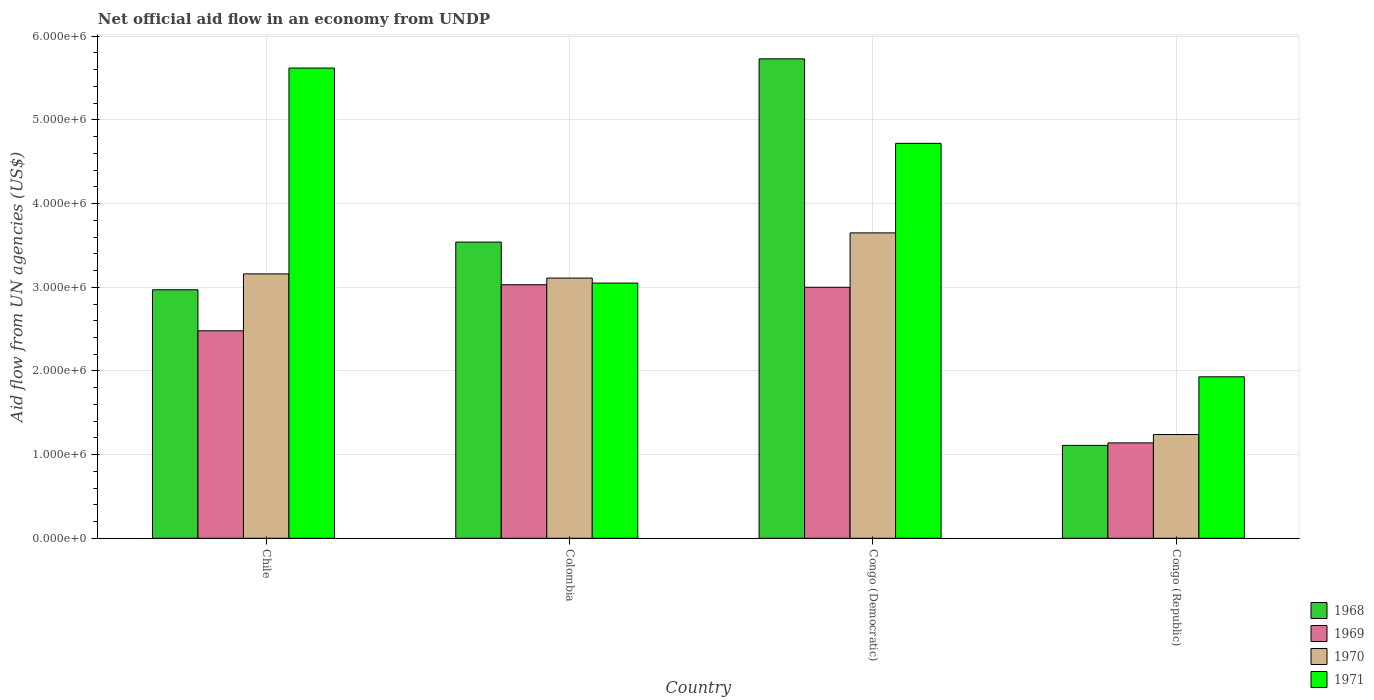How many different coloured bars are there?
Your answer should be compact. 4. Are the number of bars per tick equal to the number of legend labels?
Ensure brevity in your answer.  Yes. Are the number of bars on each tick of the X-axis equal?
Your answer should be compact. Yes. How many bars are there on the 4th tick from the left?
Offer a terse response. 4. What is the label of the 4th group of bars from the left?
Offer a terse response. Congo (Republic). In how many cases, is the number of bars for a given country not equal to the number of legend labels?
Give a very brief answer. 0. What is the net official aid flow in 1969 in Congo (Republic)?
Provide a short and direct response. 1.14e+06. Across all countries, what is the maximum net official aid flow in 1970?
Provide a succinct answer. 3.65e+06. Across all countries, what is the minimum net official aid flow in 1971?
Offer a terse response. 1.93e+06. In which country was the net official aid flow in 1969 maximum?
Keep it short and to the point. Colombia. In which country was the net official aid flow in 1968 minimum?
Your answer should be very brief. Congo (Republic). What is the total net official aid flow in 1971 in the graph?
Offer a terse response. 1.53e+07. What is the difference between the net official aid flow in 1968 in Colombia and that in Congo (Democratic)?
Provide a short and direct response. -2.19e+06. What is the difference between the net official aid flow in 1970 in Chile and the net official aid flow in 1969 in Colombia?
Make the answer very short. 1.30e+05. What is the average net official aid flow in 1971 per country?
Keep it short and to the point. 3.83e+06. In how many countries, is the net official aid flow in 1969 greater than 4400000 US$?
Offer a very short reply. 0. What is the ratio of the net official aid flow in 1971 in Chile to that in Colombia?
Provide a short and direct response. 1.84. Is the difference between the net official aid flow in 1970 in Colombia and Congo (Democratic) greater than the difference between the net official aid flow in 1969 in Colombia and Congo (Democratic)?
Offer a terse response. No. What is the difference between the highest and the second highest net official aid flow in 1969?
Offer a very short reply. 5.50e+05. What is the difference between the highest and the lowest net official aid flow in 1970?
Ensure brevity in your answer.  2.41e+06. In how many countries, is the net official aid flow in 1968 greater than the average net official aid flow in 1968 taken over all countries?
Offer a very short reply. 2. Is it the case that in every country, the sum of the net official aid flow in 1968 and net official aid flow in 1970 is greater than the sum of net official aid flow in 1969 and net official aid flow in 1971?
Make the answer very short. No. What does the 1st bar from the left in Congo (Republic) represents?
Provide a short and direct response. 1968. How many countries are there in the graph?
Provide a short and direct response. 4. What is the difference between two consecutive major ticks on the Y-axis?
Your answer should be compact. 1.00e+06. Are the values on the major ticks of Y-axis written in scientific E-notation?
Give a very brief answer. Yes. How many legend labels are there?
Your answer should be compact. 4. What is the title of the graph?
Keep it short and to the point. Net official aid flow in an economy from UNDP. Does "1999" appear as one of the legend labels in the graph?
Provide a short and direct response. No. What is the label or title of the Y-axis?
Provide a succinct answer. Aid flow from UN agencies (US$). What is the Aid flow from UN agencies (US$) in 1968 in Chile?
Ensure brevity in your answer.  2.97e+06. What is the Aid flow from UN agencies (US$) in 1969 in Chile?
Your answer should be very brief. 2.48e+06. What is the Aid flow from UN agencies (US$) in 1970 in Chile?
Provide a succinct answer. 3.16e+06. What is the Aid flow from UN agencies (US$) in 1971 in Chile?
Make the answer very short. 5.62e+06. What is the Aid flow from UN agencies (US$) in 1968 in Colombia?
Ensure brevity in your answer.  3.54e+06. What is the Aid flow from UN agencies (US$) of 1969 in Colombia?
Your answer should be very brief. 3.03e+06. What is the Aid flow from UN agencies (US$) in 1970 in Colombia?
Your answer should be very brief. 3.11e+06. What is the Aid flow from UN agencies (US$) in 1971 in Colombia?
Offer a terse response. 3.05e+06. What is the Aid flow from UN agencies (US$) of 1968 in Congo (Democratic)?
Offer a very short reply. 5.73e+06. What is the Aid flow from UN agencies (US$) in 1969 in Congo (Democratic)?
Give a very brief answer. 3.00e+06. What is the Aid flow from UN agencies (US$) of 1970 in Congo (Democratic)?
Your answer should be compact. 3.65e+06. What is the Aid flow from UN agencies (US$) of 1971 in Congo (Democratic)?
Your response must be concise. 4.72e+06. What is the Aid flow from UN agencies (US$) in 1968 in Congo (Republic)?
Ensure brevity in your answer.  1.11e+06. What is the Aid flow from UN agencies (US$) in 1969 in Congo (Republic)?
Your answer should be compact. 1.14e+06. What is the Aid flow from UN agencies (US$) in 1970 in Congo (Republic)?
Provide a short and direct response. 1.24e+06. What is the Aid flow from UN agencies (US$) of 1971 in Congo (Republic)?
Provide a short and direct response. 1.93e+06. Across all countries, what is the maximum Aid flow from UN agencies (US$) in 1968?
Your response must be concise. 5.73e+06. Across all countries, what is the maximum Aid flow from UN agencies (US$) in 1969?
Offer a terse response. 3.03e+06. Across all countries, what is the maximum Aid flow from UN agencies (US$) of 1970?
Provide a succinct answer. 3.65e+06. Across all countries, what is the maximum Aid flow from UN agencies (US$) of 1971?
Keep it short and to the point. 5.62e+06. Across all countries, what is the minimum Aid flow from UN agencies (US$) of 1968?
Offer a very short reply. 1.11e+06. Across all countries, what is the minimum Aid flow from UN agencies (US$) of 1969?
Your response must be concise. 1.14e+06. Across all countries, what is the minimum Aid flow from UN agencies (US$) of 1970?
Your answer should be very brief. 1.24e+06. Across all countries, what is the minimum Aid flow from UN agencies (US$) of 1971?
Your answer should be compact. 1.93e+06. What is the total Aid flow from UN agencies (US$) in 1968 in the graph?
Your response must be concise. 1.34e+07. What is the total Aid flow from UN agencies (US$) in 1969 in the graph?
Offer a terse response. 9.65e+06. What is the total Aid flow from UN agencies (US$) of 1970 in the graph?
Your answer should be compact. 1.12e+07. What is the total Aid flow from UN agencies (US$) of 1971 in the graph?
Provide a short and direct response. 1.53e+07. What is the difference between the Aid flow from UN agencies (US$) in 1968 in Chile and that in Colombia?
Keep it short and to the point. -5.70e+05. What is the difference between the Aid flow from UN agencies (US$) in 1969 in Chile and that in Colombia?
Your answer should be very brief. -5.50e+05. What is the difference between the Aid flow from UN agencies (US$) of 1971 in Chile and that in Colombia?
Provide a short and direct response. 2.57e+06. What is the difference between the Aid flow from UN agencies (US$) in 1968 in Chile and that in Congo (Democratic)?
Offer a very short reply. -2.76e+06. What is the difference between the Aid flow from UN agencies (US$) of 1969 in Chile and that in Congo (Democratic)?
Offer a very short reply. -5.20e+05. What is the difference between the Aid flow from UN agencies (US$) of 1970 in Chile and that in Congo (Democratic)?
Offer a terse response. -4.90e+05. What is the difference between the Aid flow from UN agencies (US$) of 1968 in Chile and that in Congo (Republic)?
Make the answer very short. 1.86e+06. What is the difference between the Aid flow from UN agencies (US$) of 1969 in Chile and that in Congo (Republic)?
Give a very brief answer. 1.34e+06. What is the difference between the Aid flow from UN agencies (US$) of 1970 in Chile and that in Congo (Republic)?
Your answer should be very brief. 1.92e+06. What is the difference between the Aid flow from UN agencies (US$) of 1971 in Chile and that in Congo (Republic)?
Offer a very short reply. 3.69e+06. What is the difference between the Aid flow from UN agencies (US$) of 1968 in Colombia and that in Congo (Democratic)?
Your answer should be compact. -2.19e+06. What is the difference between the Aid flow from UN agencies (US$) of 1969 in Colombia and that in Congo (Democratic)?
Your answer should be very brief. 3.00e+04. What is the difference between the Aid flow from UN agencies (US$) of 1970 in Colombia and that in Congo (Democratic)?
Ensure brevity in your answer.  -5.40e+05. What is the difference between the Aid flow from UN agencies (US$) in 1971 in Colombia and that in Congo (Democratic)?
Keep it short and to the point. -1.67e+06. What is the difference between the Aid flow from UN agencies (US$) in 1968 in Colombia and that in Congo (Republic)?
Offer a very short reply. 2.43e+06. What is the difference between the Aid flow from UN agencies (US$) in 1969 in Colombia and that in Congo (Republic)?
Your response must be concise. 1.89e+06. What is the difference between the Aid flow from UN agencies (US$) of 1970 in Colombia and that in Congo (Republic)?
Offer a terse response. 1.87e+06. What is the difference between the Aid flow from UN agencies (US$) of 1971 in Colombia and that in Congo (Republic)?
Your answer should be very brief. 1.12e+06. What is the difference between the Aid flow from UN agencies (US$) of 1968 in Congo (Democratic) and that in Congo (Republic)?
Offer a terse response. 4.62e+06. What is the difference between the Aid flow from UN agencies (US$) of 1969 in Congo (Democratic) and that in Congo (Republic)?
Offer a very short reply. 1.86e+06. What is the difference between the Aid flow from UN agencies (US$) in 1970 in Congo (Democratic) and that in Congo (Republic)?
Ensure brevity in your answer.  2.41e+06. What is the difference between the Aid flow from UN agencies (US$) of 1971 in Congo (Democratic) and that in Congo (Republic)?
Your answer should be very brief. 2.79e+06. What is the difference between the Aid flow from UN agencies (US$) of 1969 in Chile and the Aid flow from UN agencies (US$) of 1970 in Colombia?
Your response must be concise. -6.30e+05. What is the difference between the Aid flow from UN agencies (US$) of 1969 in Chile and the Aid flow from UN agencies (US$) of 1971 in Colombia?
Provide a succinct answer. -5.70e+05. What is the difference between the Aid flow from UN agencies (US$) in 1970 in Chile and the Aid flow from UN agencies (US$) in 1971 in Colombia?
Provide a short and direct response. 1.10e+05. What is the difference between the Aid flow from UN agencies (US$) of 1968 in Chile and the Aid flow from UN agencies (US$) of 1969 in Congo (Democratic)?
Offer a terse response. -3.00e+04. What is the difference between the Aid flow from UN agencies (US$) of 1968 in Chile and the Aid flow from UN agencies (US$) of 1970 in Congo (Democratic)?
Your answer should be compact. -6.80e+05. What is the difference between the Aid flow from UN agencies (US$) in 1968 in Chile and the Aid flow from UN agencies (US$) in 1971 in Congo (Democratic)?
Give a very brief answer. -1.75e+06. What is the difference between the Aid flow from UN agencies (US$) of 1969 in Chile and the Aid flow from UN agencies (US$) of 1970 in Congo (Democratic)?
Keep it short and to the point. -1.17e+06. What is the difference between the Aid flow from UN agencies (US$) in 1969 in Chile and the Aid flow from UN agencies (US$) in 1971 in Congo (Democratic)?
Your response must be concise. -2.24e+06. What is the difference between the Aid flow from UN agencies (US$) in 1970 in Chile and the Aid flow from UN agencies (US$) in 1971 in Congo (Democratic)?
Give a very brief answer. -1.56e+06. What is the difference between the Aid flow from UN agencies (US$) of 1968 in Chile and the Aid flow from UN agencies (US$) of 1969 in Congo (Republic)?
Give a very brief answer. 1.83e+06. What is the difference between the Aid flow from UN agencies (US$) in 1968 in Chile and the Aid flow from UN agencies (US$) in 1970 in Congo (Republic)?
Offer a terse response. 1.73e+06. What is the difference between the Aid flow from UN agencies (US$) in 1968 in Chile and the Aid flow from UN agencies (US$) in 1971 in Congo (Republic)?
Your answer should be very brief. 1.04e+06. What is the difference between the Aid flow from UN agencies (US$) of 1969 in Chile and the Aid flow from UN agencies (US$) of 1970 in Congo (Republic)?
Give a very brief answer. 1.24e+06. What is the difference between the Aid flow from UN agencies (US$) in 1969 in Chile and the Aid flow from UN agencies (US$) in 1971 in Congo (Republic)?
Offer a very short reply. 5.50e+05. What is the difference between the Aid flow from UN agencies (US$) of 1970 in Chile and the Aid flow from UN agencies (US$) of 1971 in Congo (Republic)?
Give a very brief answer. 1.23e+06. What is the difference between the Aid flow from UN agencies (US$) of 1968 in Colombia and the Aid flow from UN agencies (US$) of 1969 in Congo (Democratic)?
Provide a succinct answer. 5.40e+05. What is the difference between the Aid flow from UN agencies (US$) of 1968 in Colombia and the Aid flow from UN agencies (US$) of 1971 in Congo (Democratic)?
Provide a short and direct response. -1.18e+06. What is the difference between the Aid flow from UN agencies (US$) of 1969 in Colombia and the Aid flow from UN agencies (US$) of 1970 in Congo (Democratic)?
Your response must be concise. -6.20e+05. What is the difference between the Aid flow from UN agencies (US$) in 1969 in Colombia and the Aid flow from UN agencies (US$) in 1971 in Congo (Democratic)?
Your response must be concise. -1.69e+06. What is the difference between the Aid flow from UN agencies (US$) in 1970 in Colombia and the Aid flow from UN agencies (US$) in 1971 in Congo (Democratic)?
Keep it short and to the point. -1.61e+06. What is the difference between the Aid flow from UN agencies (US$) in 1968 in Colombia and the Aid flow from UN agencies (US$) in 1969 in Congo (Republic)?
Offer a very short reply. 2.40e+06. What is the difference between the Aid flow from UN agencies (US$) of 1968 in Colombia and the Aid flow from UN agencies (US$) of 1970 in Congo (Republic)?
Keep it short and to the point. 2.30e+06. What is the difference between the Aid flow from UN agencies (US$) in 1968 in Colombia and the Aid flow from UN agencies (US$) in 1971 in Congo (Republic)?
Provide a short and direct response. 1.61e+06. What is the difference between the Aid flow from UN agencies (US$) of 1969 in Colombia and the Aid flow from UN agencies (US$) of 1970 in Congo (Republic)?
Make the answer very short. 1.79e+06. What is the difference between the Aid flow from UN agencies (US$) of 1969 in Colombia and the Aid flow from UN agencies (US$) of 1971 in Congo (Republic)?
Ensure brevity in your answer.  1.10e+06. What is the difference between the Aid flow from UN agencies (US$) in 1970 in Colombia and the Aid flow from UN agencies (US$) in 1971 in Congo (Republic)?
Offer a terse response. 1.18e+06. What is the difference between the Aid flow from UN agencies (US$) of 1968 in Congo (Democratic) and the Aid flow from UN agencies (US$) of 1969 in Congo (Republic)?
Your answer should be very brief. 4.59e+06. What is the difference between the Aid flow from UN agencies (US$) of 1968 in Congo (Democratic) and the Aid flow from UN agencies (US$) of 1970 in Congo (Republic)?
Keep it short and to the point. 4.49e+06. What is the difference between the Aid flow from UN agencies (US$) of 1968 in Congo (Democratic) and the Aid flow from UN agencies (US$) of 1971 in Congo (Republic)?
Provide a short and direct response. 3.80e+06. What is the difference between the Aid flow from UN agencies (US$) of 1969 in Congo (Democratic) and the Aid flow from UN agencies (US$) of 1970 in Congo (Republic)?
Provide a short and direct response. 1.76e+06. What is the difference between the Aid flow from UN agencies (US$) in 1969 in Congo (Democratic) and the Aid flow from UN agencies (US$) in 1971 in Congo (Republic)?
Your answer should be compact. 1.07e+06. What is the difference between the Aid flow from UN agencies (US$) of 1970 in Congo (Democratic) and the Aid flow from UN agencies (US$) of 1971 in Congo (Republic)?
Provide a succinct answer. 1.72e+06. What is the average Aid flow from UN agencies (US$) of 1968 per country?
Your answer should be compact. 3.34e+06. What is the average Aid flow from UN agencies (US$) in 1969 per country?
Ensure brevity in your answer.  2.41e+06. What is the average Aid flow from UN agencies (US$) in 1970 per country?
Your response must be concise. 2.79e+06. What is the average Aid flow from UN agencies (US$) of 1971 per country?
Ensure brevity in your answer.  3.83e+06. What is the difference between the Aid flow from UN agencies (US$) in 1968 and Aid flow from UN agencies (US$) in 1969 in Chile?
Your response must be concise. 4.90e+05. What is the difference between the Aid flow from UN agencies (US$) in 1968 and Aid flow from UN agencies (US$) in 1971 in Chile?
Provide a short and direct response. -2.65e+06. What is the difference between the Aid flow from UN agencies (US$) of 1969 and Aid flow from UN agencies (US$) of 1970 in Chile?
Your answer should be compact. -6.80e+05. What is the difference between the Aid flow from UN agencies (US$) of 1969 and Aid flow from UN agencies (US$) of 1971 in Chile?
Offer a terse response. -3.14e+06. What is the difference between the Aid flow from UN agencies (US$) of 1970 and Aid flow from UN agencies (US$) of 1971 in Chile?
Your answer should be very brief. -2.46e+06. What is the difference between the Aid flow from UN agencies (US$) of 1968 and Aid flow from UN agencies (US$) of 1969 in Colombia?
Offer a very short reply. 5.10e+05. What is the difference between the Aid flow from UN agencies (US$) in 1968 and Aid flow from UN agencies (US$) in 1971 in Colombia?
Give a very brief answer. 4.90e+05. What is the difference between the Aid flow from UN agencies (US$) of 1969 and Aid flow from UN agencies (US$) of 1970 in Colombia?
Your response must be concise. -8.00e+04. What is the difference between the Aid flow from UN agencies (US$) in 1970 and Aid flow from UN agencies (US$) in 1971 in Colombia?
Offer a terse response. 6.00e+04. What is the difference between the Aid flow from UN agencies (US$) of 1968 and Aid flow from UN agencies (US$) of 1969 in Congo (Democratic)?
Offer a terse response. 2.73e+06. What is the difference between the Aid flow from UN agencies (US$) in 1968 and Aid flow from UN agencies (US$) in 1970 in Congo (Democratic)?
Provide a short and direct response. 2.08e+06. What is the difference between the Aid flow from UN agencies (US$) of 1968 and Aid flow from UN agencies (US$) of 1971 in Congo (Democratic)?
Give a very brief answer. 1.01e+06. What is the difference between the Aid flow from UN agencies (US$) of 1969 and Aid flow from UN agencies (US$) of 1970 in Congo (Democratic)?
Keep it short and to the point. -6.50e+05. What is the difference between the Aid flow from UN agencies (US$) in 1969 and Aid flow from UN agencies (US$) in 1971 in Congo (Democratic)?
Keep it short and to the point. -1.72e+06. What is the difference between the Aid flow from UN agencies (US$) of 1970 and Aid flow from UN agencies (US$) of 1971 in Congo (Democratic)?
Offer a very short reply. -1.07e+06. What is the difference between the Aid flow from UN agencies (US$) in 1968 and Aid flow from UN agencies (US$) in 1969 in Congo (Republic)?
Provide a succinct answer. -3.00e+04. What is the difference between the Aid flow from UN agencies (US$) in 1968 and Aid flow from UN agencies (US$) in 1970 in Congo (Republic)?
Provide a succinct answer. -1.30e+05. What is the difference between the Aid flow from UN agencies (US$) of 1968 and Aid flow from UN agencies (US$) of 1971 in Congo (Republic)?
Your response must be concise. -8.20e+05. What is the difference between the Aid flow from UN agencies (US$) in 1969 and Aid flow from UN agencies (US$) in 1970 in Congo (Republic)?
Offer a very short reply. -1.00e+05. What is the difference between the Aid flow from UN agencies (US$) in 1969 and Aid flow from UN agencies (US$) in 1971 in Congo (Republic)?
Your answer should be compact. -7.90e+05. What is the difference between the Aid flow from UN agencies (US$) of 1970 and Aid flow from UN agencies (US$) of 1971 in Congo (Republic)?
Your response must be concise. -6.90e+05. What is the ratio of the Aid flow from UN agencies (US$) in 1968 in Chile to that in Colombia?
Make the answer very short. 0.84. What is the ratio of the Aid flow from UN agencies (US$) in 1969 in Chile to that in Colombia?
Provide a short and direct response. 0.82. What is the ratio of the Aid flow from UN agencies (US$) of 1970 in Chile to that in Colombia?
Make the answer very short. 1.02. What is the ratio of the Aid flow from UN agencies (US$) in 1971 in Chile to that in Colombia?
Offer a terse response. 1.84. What is the ratio of the Aid flow from UN agencies (US$) in 1968 in Chile to that in Congo (Democratic)?
Make the answer very short. 0.52. What is the ratio of the Aid flow from UN agencies (US$) of 1969 in Chile to that in Congo (Democratic)?
Your response must be concise. 0.83. What is the ratio of the Aid flow from UN agencies (US$) of 1970 in Chile to that in Congo (Democratic)?
Provide a succinct answer. 0.87. What is the ratio of the Aid flow from UN agencies (US$) of 1971 in Chile to that in Congo (Democratic)?
Make the answer very short. 1.19. What is the ratio of the Aid flow from UN agencies (US$) of 1968 in Chile to that in Congo (Republic)?
Give a very brief answer. 2.68. What is the ratio of the Aid flow from UN agencies (US$) of 1969 in Chile to that in Congo (Republic)?
Your response must be concise. 2.18. What is the ratio of the Aid flow from UN agencies (US$) of 1970 in Chile to that in Congo (Republic)?
Make the answer very short. 2.55. What is the ratio of the Aid flow from UN agencies (US$) in 1971 in Chile to that in Congo (Republic)?
Offer a terse response. 2.91. What is the ratio of the Aid flow from UN agencies (US$) in 1968 in Colombia to that in Congo (Democratic)?
Your answer should be very brief. 0.62. What is the ratio of the Aid flow from UN agencies (US$) of 1970 in Colombia to that in Congo (Democratic)?
Your answer should be compact. 0.85. What is the ratio of the Aid flow from UN agencies (US$) in 1971 in Colombia to that in Congo (Democratic)?
Your response must be concise. 0.65. What is the ratio of the Aid flow from UN agencies (US$) of 1968 in Colombia to that in Congo (Republic)?
Provide a succinct answer. 3.19. What is the ratio of the Aid flow from UN agencies (US$) of 1969 in Colombia to that in Congo (Republic)?
Your answer should be very brief. 2.66. What is the ratio of the Aid flow from UN agencies (US$) of 1970 in Colombia to that in Congo (Republic)?
Your answer should be very brief. 2.51. What is the ratio of the Aid flow from UN agencies (US$) in 1971 in Colombia to that in Congo (Republic)?
Offer a terse response. 1.58. What is the ratio of the Aid flow from UN agencies (US$) of 1968 in Congo (Democratic) to that in Congo (Republic)?
Give a very brief answer. 5.16. What is the ratio of the Aid flow from UN agencies (US$) in 1969 in Congo (Democratic) to that in Congo (Republic)?
Provide a succinct answer. 2.63. What is the ratio of the Aid flow from UN agencies (US$) of 1970 in Congo (Democratic) to that in Congo (Republic)?
Your answer should be compact. 2.94. What is the ratio of the Aid flow from UN agencies (US$) of 1971 in Congo (Democratic) to that in Congo (Republic)?
Offer a very short reply. 2.45. What is the difference between the highest and the second highest Aid flow from UN agencies (US$) in 1968?
Provide a succinct answer. 2.19e+06. What is the difference between the highest and the second highest Aid flow from UN agencies (US$) in 1969?
Your response must be concise. 3.00e+04. What is the difference between the highest and the second highest Aid flow from UN agencies (US$) in 1970?
Ensure brevity in your answer.  4.90e+05. What is the difference between the highest and the lowest Aid flow from UN agencies (US$) of 1968?
Provide a short and direct response. 4.62e+06. What is the difference between the highest and the lowest Aid flow from UN agencies (US$) of 1969?
Keep it short and to the point. 1.89e+06. What is the difference between the highest and the lowest Aid flow from UN agencies (US$) of 1970?
Keep it short and to the point. 2.41e+06. What is the difference between the highest and the lowest Aid flow from UN agencies (US$) of 1971?
Ensure brevity in your answer.  3.69e+06. 